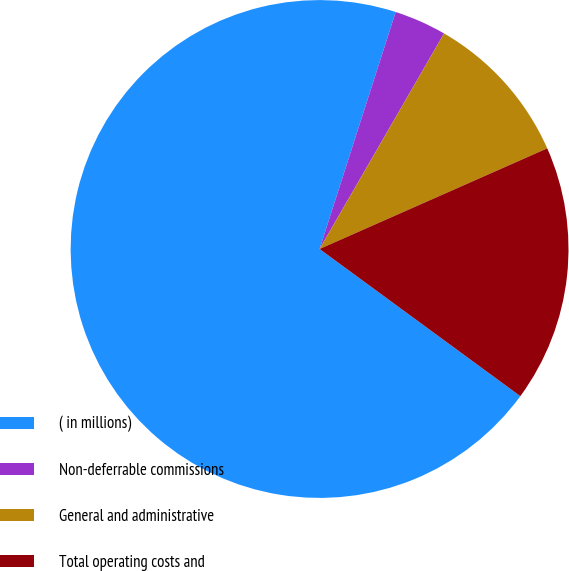Convert chart. <chart><loc_0><loc_0><loc_500><loc_500><pie_chart><fcel>( in millions)<fcel>Non-deferrable commissions<fcel>General and administrative<fcel>Total operating costs and<nl><fcel>69.87%<fcel>3.39%<fcel>10.04%<fcel>16.69%<nl></chart> 